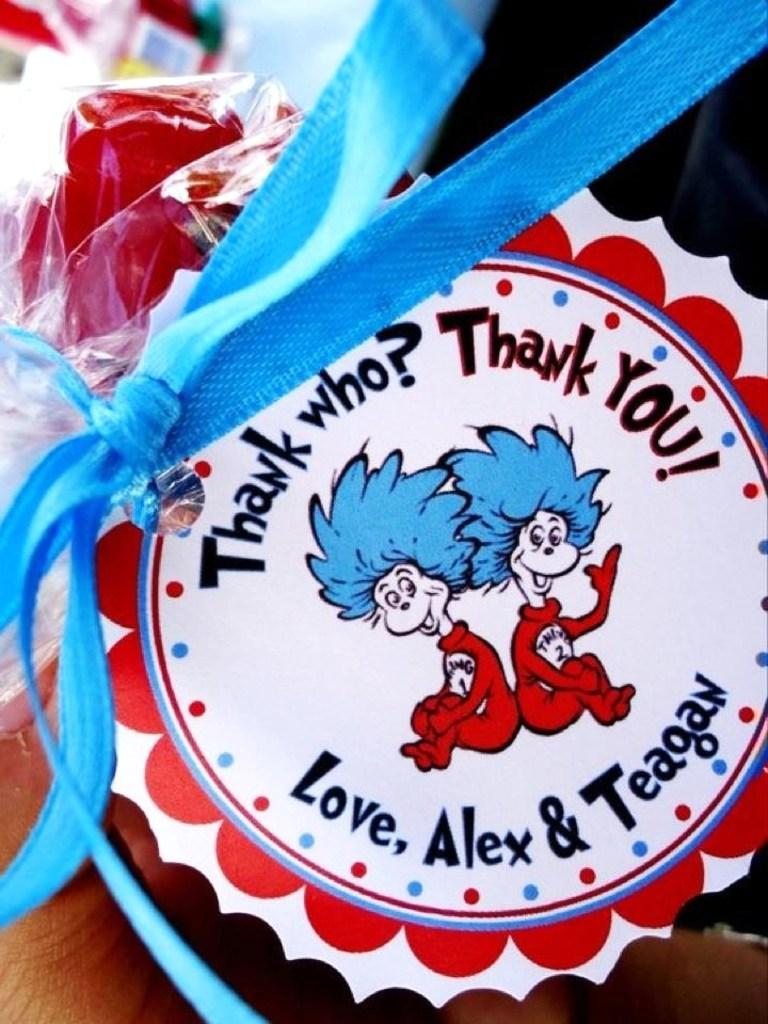What can be seen in the image that resembles an award or recognition? There is a badge in the image. What color is the ribbon on the badge? The badge has a blue ribbon. Can you describe the background of the image? The background of the image is blurred. What type of sack is being used to communicate in the image? There is no sack present in the image, and no communication is taking place. How many turkeys can be seen in the image? There are no turkeys present in the image. 